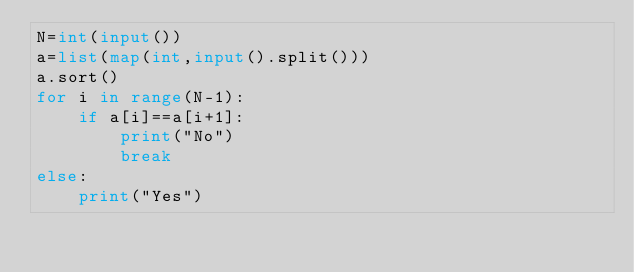Convert code to text. <code><loc_0><loc_0><loc_500><loc_500><_Python_>N=int(input())
a=list(map(int,input().split()))
a.sort()
for i in range(N-1):
    if a[i]==a[i+1]:
        print("No")
        break
else:
    print("Yes")</code> 